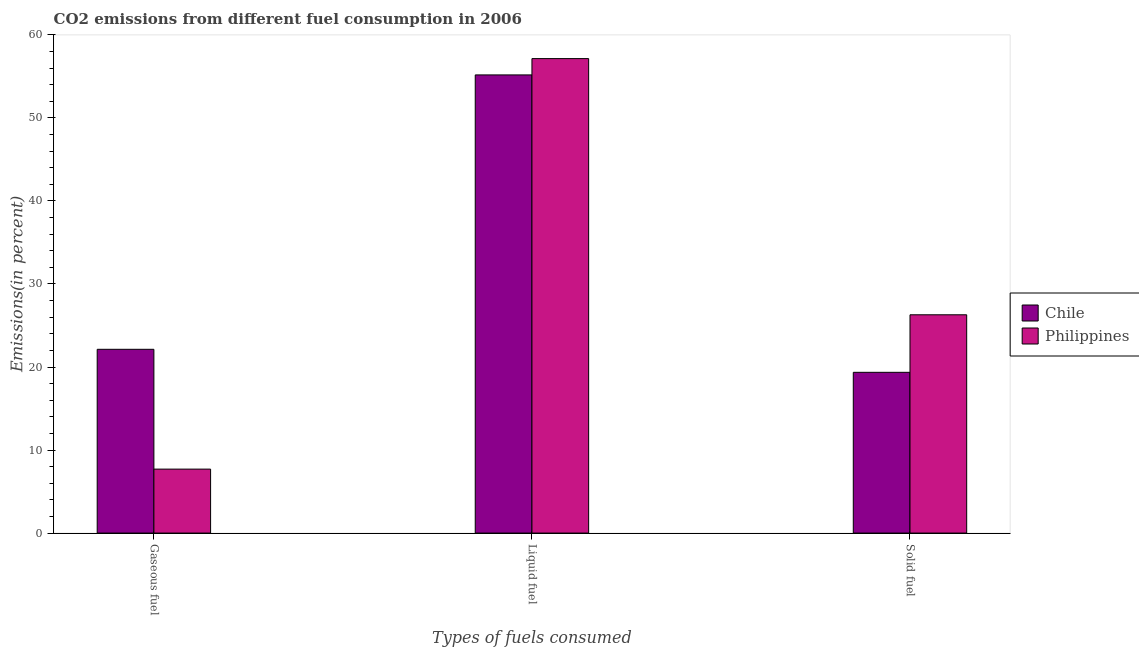Are the number of bars on each tick of the X-axis equal?
Make the answer very short. Yes. How many bars are there on the 3rd tick from the left?
Offer a terse response. 2. How many bars are there on the 3rd tick from the right?
Your answer should be very brief. 2. What is the label of the 2nd group of bars from the left?
Ensure brevity in your answer.  Liquid fuel. What is the percentage of solid fuel emission in Philippines?
Give a very brief answer. 26.29. Across all countries, what is the maximum percentage of liquid fuel emission?
Make the answer very short. 57.15. Across all countries, what is the minimum percentage of solid fuel emission?
Give a very brief answer. 19.36. In which country was the percentage of gaseous fuel emission minimum?
Your response must be concise. Philippines. What is the total percentage of gaseous fuel emission in the graph?
Provide a succinct answer. 29.84. What is the difference between the percentage of solid fuel emission in Philippines and that in Chile?
Keep it short and to the point. 6.93. What is the difference between the percentage of liquid fuel emission in Chile and the percentage of solid fuel emission in Philippines?
Give a very brief answer. 28.89. What is the average percentage of liquid fuel emission per country?
Offer a very short reply. 56.16. What is the difference between the percentage of liquid fuel emission and percentage of gaseous fuel emission in Philippines?
Your answer should be very brief. 49.44. In how many countries, is the percentage of liquid fuel emission greater than 4 %?
Your response must be concise. 2. What is the ratio of the percentage of solid fuel emission in Philippines to that in Chile?
Provide a succinct answer. 1.36. What is the difference between the highest and the second highest percentage of liquid fuel emission?
Your answer should be very brief. 1.97. What is the difference between the highest and the lowest percentage of liquid fuel emission?
Keep it short and to the point. 1.97. In how many countries, is the percentage of solid fuel emission greater than the average percentage of solid fuel emission taken over all countries?
Your answer should be very brief. 1. What does the 2nd bar from the right in Solid fuel represents?
Your answer should be very brief. Chile. Is it the case that in every country, the sum of the percentage of gaseous fuel emission and percentage of liquid fuel emission is greater than the percentage of solid fuel emission?
Provide a succinct answer. Yes. How many countries are there in the graph?
Your answer should be compact. 2. What is the difference between two consecutive major ticks on the Y-axis?
Give a very brief answer. 10. Are the values on the major ticks of Y-axis written in scientific E-notation?
Provide a succinct answer. No. Does the graph contain any zero values?
Make the answer very short. No. What is the title of the graph?
Your answer should be compact. CO2 emissions from different fuel consumption in 2006. What is the label or title of the X-axis?
Your answer should be compact. Types of fuels consumed. What is the label or title of the Y-axis?
Give a very brief answer. Emissions(in percent). What is the Emissions(in percent) of Chile in Gaseous fuel?
Your answer should be very brief. 22.13. What is the Emissions(in percent) of Philippines in Gaseous fuel?
Keep it short and to the point. 7.7. What is the Emissions(in percent) in Chile in Liquid fuel?
Offer a very short reply. 55.18. What is the Emissions(in percent) in Philippines in Liquid fuel?
Offer a terse response. 57.15. What is the Emissions(in percent) of Chile in Solid fuel?
Your answer should be very brief. 19.36. What is the Emissions(in percent) in Philippines in Solid fuel?
Ensure brevity in your answer.  26.29. Across all Types of fuels consumed, what is the maximum Emissions(in percent) of Chile?
Make the answer very short. 55.18. Across all Types of fuels consumed, what is the maximum Emissions(in percent) of Philippines?
Provide a succinct answer. 57.15. Across all Types of fuels consumed, what is the minimum Emissions(in percent) of Chile?
Your answer should be compact. 19.36. Across all Types of fuels consumed, what is the minimum Emissions(in percent) of Philippines?
Your answer should be compact. 7.7. What is the total Emissions(in percent) of Chile in the graph?
Make the answer very short. 96.67. What is the total Emissions(in percent) in Philippines in the graph?
Ensure brevity in your answer.  91.14. What is the difference between the Emissions(in percent) in Chile in Gaseous fuel and that in Liquid fuel?
Your answer should be compact. -33.05. What is the difference between the Emissions(in percent) in Philippines in Gaseous fuel and that in Liquid fuel?
Offer a very short reply. -49.44. What is the difference between the Emissions(in percent) of Chile in Gaseous fuel and that in Solid fuel?
Keep it short and to the point. 2.77. What is the difference between the Emissions(in percent) of Philippines in Gaseous fuel and that in Solid fuel?
Your answer should be very brief. -18.59. What is the difference between the Emissions(in percent) of Chile in Liquid fuel and that in Solid fuel?
Your response must be concise. 35.82. What is the difference between the Emissions(in percent) of Philippines in Liquid fuel and that in Solid fuel?
Offer a terse response. 30.86. What is the difference between the Emissions(in percent) in Chile in Gaseous fuel and the Emissions(in percent) in Philippines in Liquid fuel?
Offer a very short reply. -35.01. What is the difference between the Emissions(in percent) in Chile in Gaseous fuel and the Emissions(in percent) in Philippines in Solid fuel?
Keep it short and to the point. -4.16. What is the difference between the Emissions(in percent) of Chile in Liquid fuel and the Emissions(in percent) of Philippines in Solid fuel?
Your answer should be very brief. 28.89. What is the average Emissions(in percent) of Chile per Types of fuels consumed?
Keep it short and to the point. 32.22. What is the average Emissions(in percent) in Philippines per Types of fuels consumed?
Offer a terse response. 30.38. What is the difference between the Emissions(in percent) of Chile and Emissions(in percent) of Philippines in Gaseous fuel?
Keep it short and to the point. 14.43. What is the difference between the Emissions(in percent) in Chile and Emissions(in percent) in Philippines in Liquid fuel?
Make the answer very short. -1.97. What is the difference between the Emissions(in percent) in Chile and Emissions(in percent) in Philippines in Solid fuel?
Ensure brevity in your answer.  -6.93. What is the ratio of the Emissions(in percent) of Chile in Gaseous fuel to that in Liquid fuel?
Provide a short and direct response. 0.4. What is the ratio of the Emissions(in percent) of Philippines in Gaseous fuel to that in Liquid fuel?
Make the answer very short. 0.13. What is the ratio of the Emissions(in percent) of Chile in Gaseous fuel to that in Solid fuel?
Give a very brief answer. 1.14. What is the ratio of the Emissions(in percent) in Philippines in Gaseous fuel to that in Solid fuel?
Ensure brevity in your answer.  0.29. What is the ratio of the Emissions(in percent) of Chile in Liquid fuel to that in Solid fuel?
Your answer should be very brief. 2.85. What is the ratio of the Emissions(in percent) of Philippines in Liquid fuel to that in Solid fuel?
Offer a very short reply. 2.17. What is the difference between the highest and the second highest Emissions(in percent) of Chile?
Your answer should be compact. 33.05. What is the difference between the highest and the second highest Emissions(in percent) in Philippines?
Give a very brief answer. 30.86. What is the difference between the highest and the lowest Emissions(in percent) of Chile?
Make the answer very short. 35.82. What is the difference between the highest and the lowest Emissions(in percent) of Philippines?
Provide a short and direct response. 49.44. 